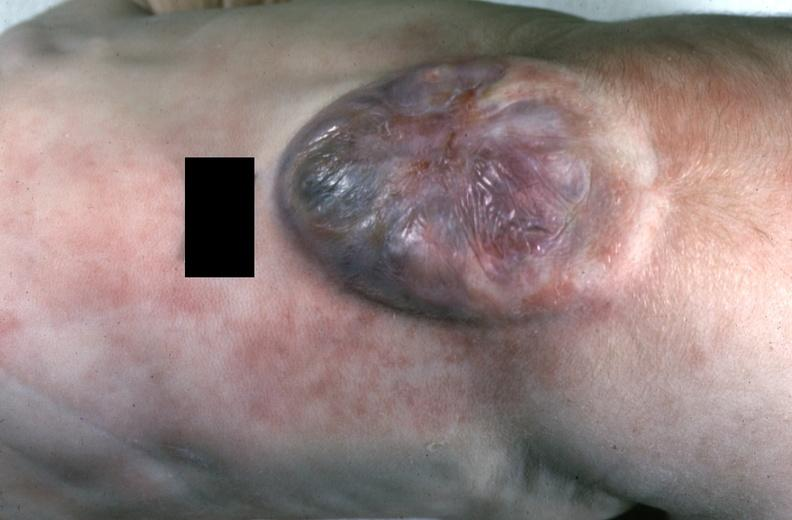does this image show neural tube defect?
Answer the question using a single word or phrase. Yes 